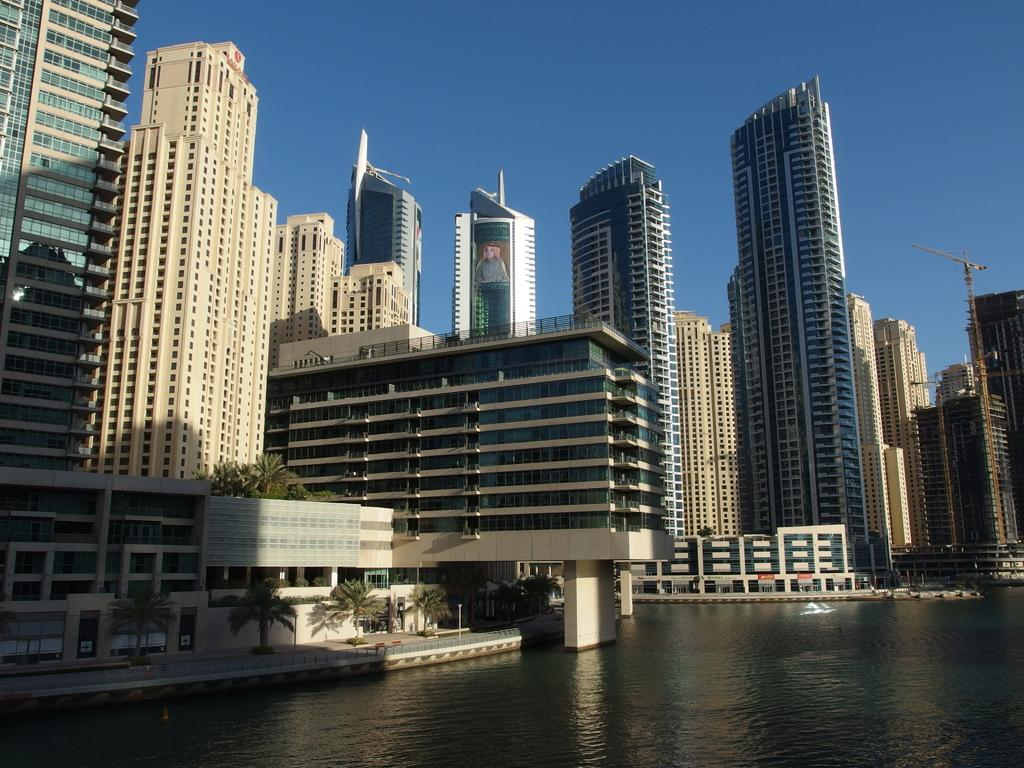What type of structures can be seen in the image? There are buildings in the image. What natural element is visible in the image? There is water visible in the image. What type of vegetation is present in the image? There are trees in the image. What part of the natural environment is visible in the image? The sky is visible in the image. Where is the beam located in the image? There is no beam present in the image. What type of coal can be seen in the image? There is no coal present in the image. 